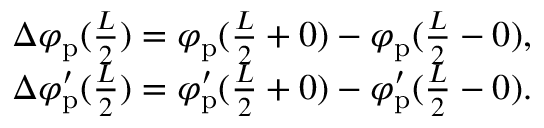<formula> <loc_0><loc_0><loc_500><loc_500>\begin{array} { r } { \Delta \varphi _ { p } ( \frac { L } { 2 } ) = \varphi _ { p } ( \frac { L } { 2 } + 0 ) - \varphi _ { p } ( \frac { L } { 2 } - 0 ) , } \\ { \Delta \varphi _ { p } ^ { \prime } ( \frac { L } { 2 } ) = \varphi _ { p } ^ { \prime } ( \frac { L } { 2 } + 0 ) - \varphi _ { p } ^ { \prime } ( \frac { L } { 2 } - 0 ) . } \end{array}</formula> 